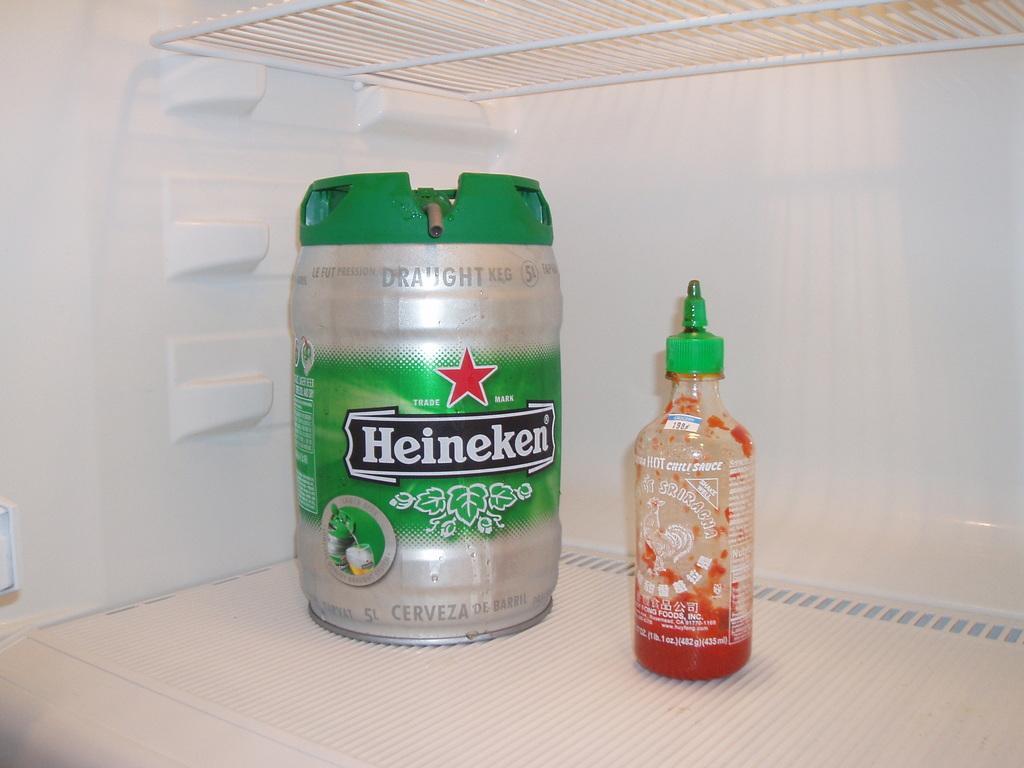Please provide a concise description of this image. Picture inside of a fridge. In this fridge there is a tin and bottle. 